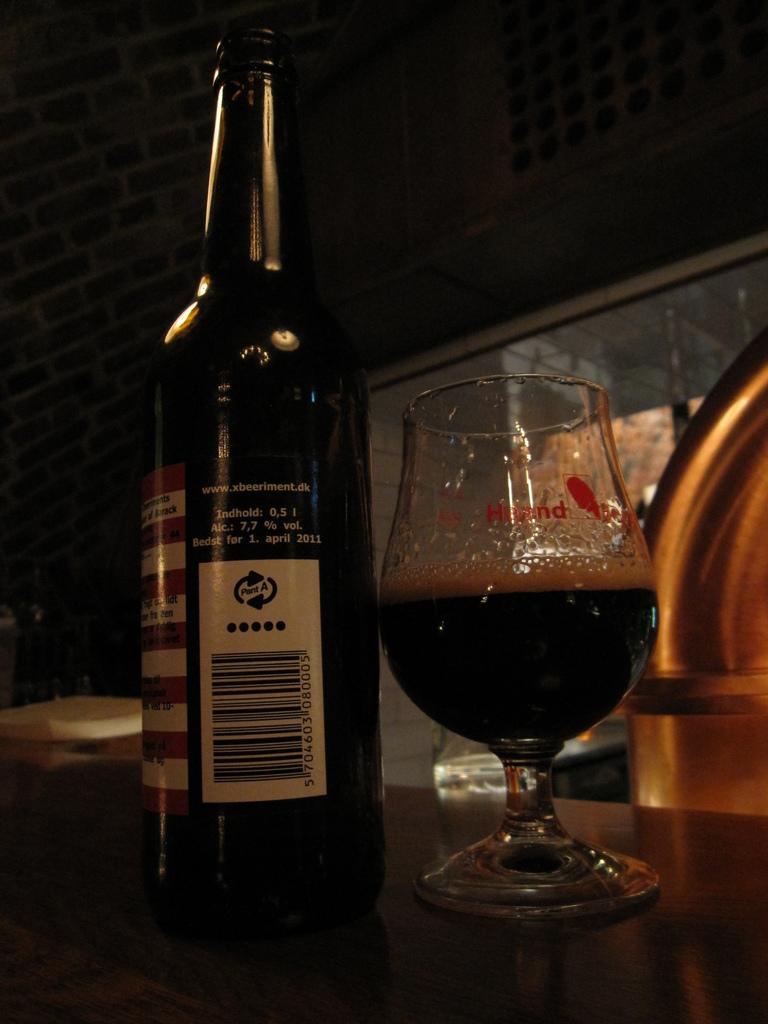Can you describe this image briefly? In this picture we can see a bottle and a glass with drink in it and these all are on the platform and in the background we can see a wall and some objects. 